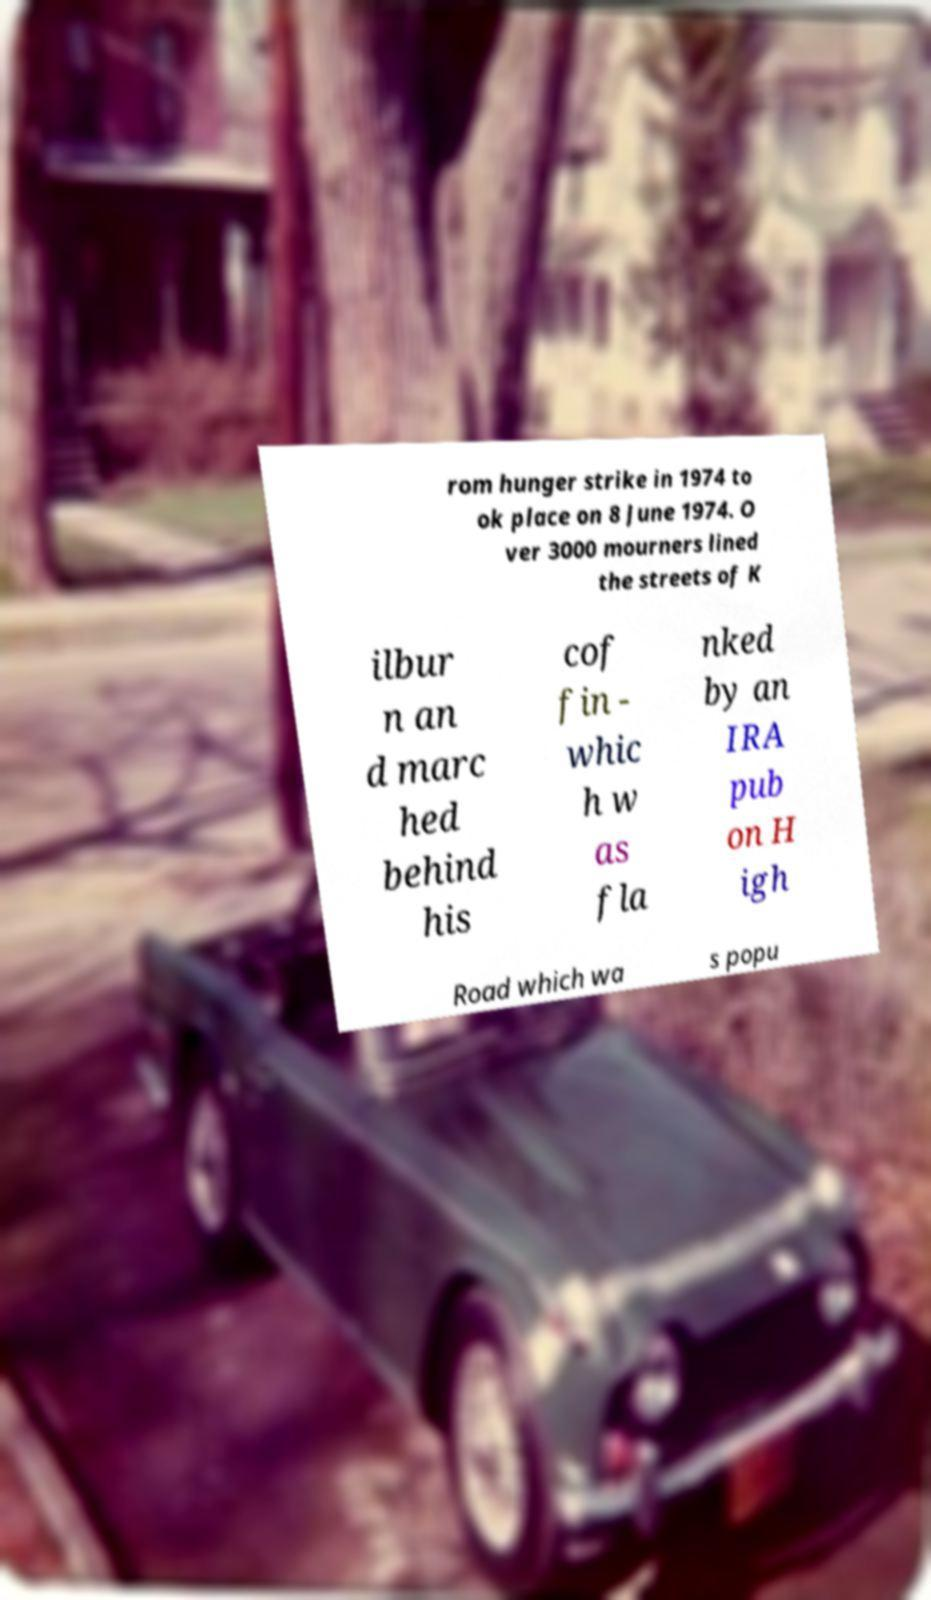Could you assist in decoding the text presented in this image and type it out clearly? rom hunger strike in 1974 to ok place on 8 June 1974. O ver 3000 mourners lined the streets of K ilbur n an d marc hed behind his cof fin - whic h w as fla nked by an IRA pub on H igh Road which wa s popu 